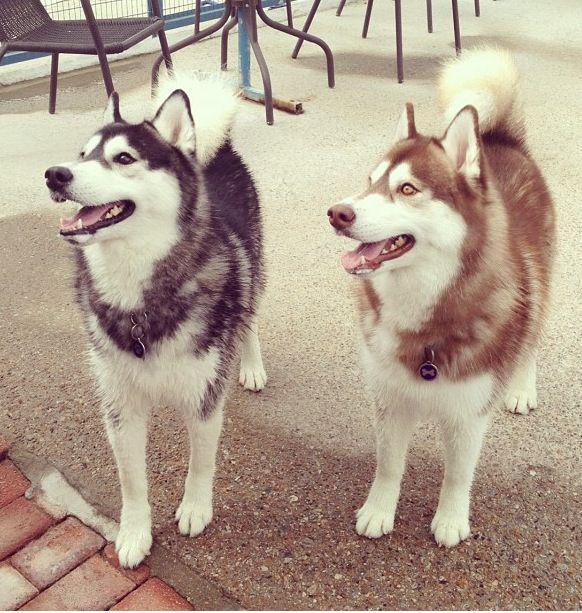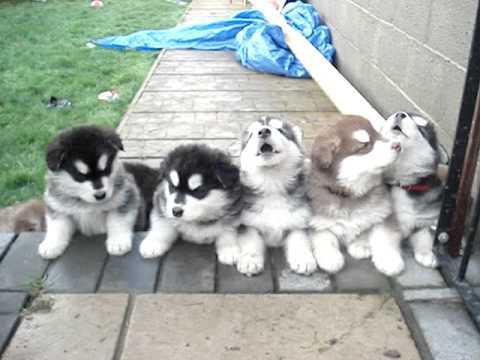The first image is the image on the left, the second image is the image on the right. For the images displayed, is the sentence "The right image shows a husky dog perched atop a rectangular table in front of something with criss-crossing lines." factually correct? Answer yes or no. No. The first image is the image on the left, the second image is the image on the right. Analyze the images presented: Is the assertion "There is at least one dog on top of a table." valid? Answer yes or no. No. 